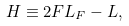<formula> <loc_0><loc_0><loc_500><loc_500>H \equiv 2 F L _ { F } - L ,</formula> 